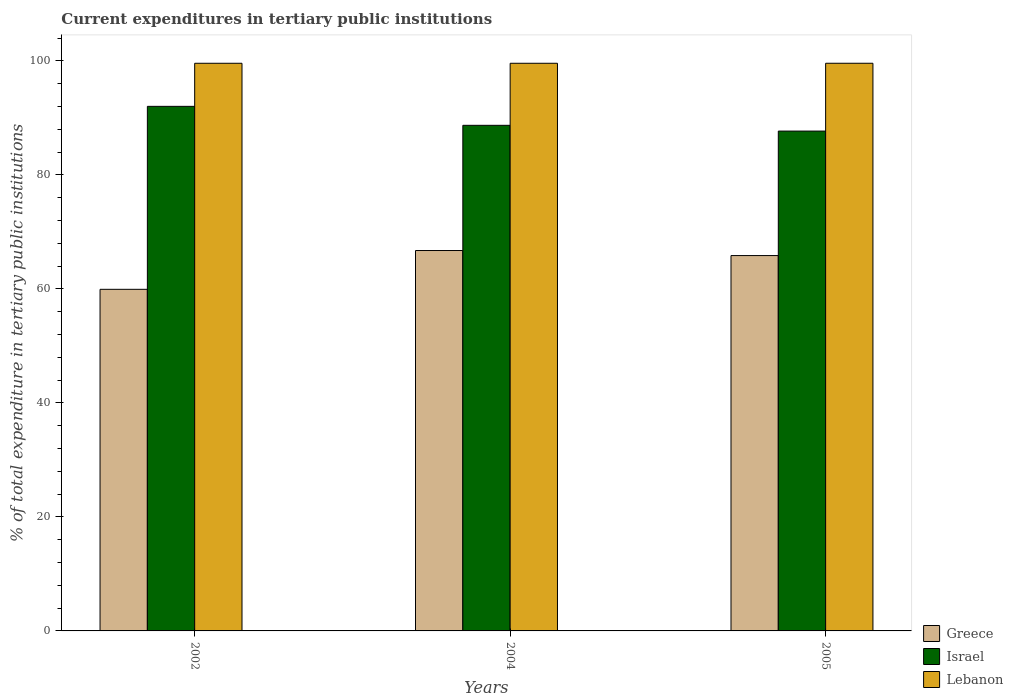How many different coloured bars are there?
Provide a succinct answer. 3. How many groups of bars are there?
Your answer should be very brief. 3. How many bars are there on the 2nd tick from the left?
Offer a very short reply. 3. How many bars are there on the 1st tick from the right?
Your response must be concise. 3. In how many cases, is the number of bars for a given year not equal to the number of legend labels?
Ensure brevity in your answer.  0. What is the current expenditures in tertiary public institutions in Israel in 2005?
Make the answer very short. 87.68. Across all years, what is the maximum current expenditures in tertiary public institutions in Israel?
Your answer should be very brief. 92.02. Across all years, what is the minimum current expenditures in tertiary public institutions in Greece?
Your response must be concise. 59.92. What is the total current expenditures in tertiary public institutions in Lebanon in the graph?
Your response must be concise. 298.72. What is the difference between the current expenditures in tertiary public institutions in Greece in 2002 and that in 2005?
Make the answer very short. -5.92. What is the difference between the current expenditures in tertiary public institutions in Lebanon in 2002 and the current expenditures in tertiary public institutions in Israel in 2004?
Make the answer very short. 10.88. What is the average current expenditures in tertiary public institutions in Israel per year?
Your answer should be very brief. 89.46. In the year 2002, what is the difference between the current expenditures in tertiary public institutions in Greece and current expenditures in tertiary public institutions in Lebanon?
Make the answer very short. -39.65. What is the ratio of the current expenditures in tertiary public institutions in Israel in 2004 to that in 2005?
Keep it short and to the point. 1.01. Is the current expenditures in tertiary public institutions in Lebanon in 2002 less than that in 2005?
Your response must be concise. Yes. What is the difference between the highest and the second highest current expenditures in tertiary public institutions in Israel?
Offer a terse response. 3.33. What is the difference between the highest and the lowest current expenditures in tertiary public institutions in Lebanon?
Ensure brevity in your answer.  0. Is the sum of the current expenditures in tertiary public institutions in Greece in 2004 and 2005 greater than the maximum current expenditures in tertiary public institutions in Israel across all years?
Your answer should be very brief. Yes. What does the 2nd bar from the left in 2005 represents?
Ensure brevity in your answer.  Israel. What does the 2nd bar from the right in 2004 represents?
Provide a short and direct response. Israel. What is the difference between two consecutive major ticks on the Y-axis?
Make the answer very short. 20. Are the values on the major ticks of Y-axis written in scientific E-notation?
Your answer should be compact. No. Does the graph contain grids?
Your answer should be very brief. No. How are the legend labels stacked?
Give a very brief answer. Vertical. What is the title of the graph?
Offer a very short reply. Current expenditures in tertiary public institutions. What is the label or title of the Y-axis?
Your answer should be compact. % of total expenditure in tertiary public institutions. What is the % of total expenditure in tertiary public institutions of Greece in 2002?
Keep it short and to the point. 59.92. What is the % of total expenditure in tertiary public institutions in Israel in 2002?
Offer a terse response. 92.02. What is the % of total expenditure in tertiary public institutions of Lebanon in 2002?
Give a very brief answer. 99.57. What is the % of total expenditure in tertiary public institutions of Greece in 2004?
Give a very brief answer. 66.73. What is the % of total expenditure in tertiary public institutions in Israel in 2004?
Your answer should be compact. 88.69. What is the % of total expenditure in tertiary public institutions of Lebanon in 2004?
Ensure brevity in your answer.  99.57. What is the % of total expenditure in tertiary public institutions of Greece in 2005?
Give a very brief answer. 65.84. What is the % of total expenditure in tertiary public institutions of Israel in 2005?
Keep it short and to the point. 87.68. What is the % of total expenditure in tertiary public institutions of Lebanon in 2005?
Provide a short and direct response. 99.58. Across all years, what is the maximum % of total expenditure in tertiary public institutions in Greece?
Give a very brief answer. 66.73. Across all years, what is the maximum % of total expenditure in tertiary public institutions in Israel?
Offer a very short reply. 92.02. Across all years, what is the maximum % of total expenditure in tertiary public institutions of Lebanon?
Your answer should be compact. 99.58. Across all years, what is the minimum % of total expenditure in tertiary public institutions of Greece?
Your answer should be compact. 59.92. Across all years, what is the minimum % of total expenditure in tertiary public institutions of Israel?
Provide a succinct answer. 87.68. Across all years, what is the minimum % of total expenditure in tertiary public institutions of Lebanon?
Provide a succinct answer. 99.57. What is the total % of total expenditure in tertiary public institutions of Greece in the graph?
Give a very brief answer. 192.49. What is the total % of total expenditure in tertiary public institutions in Israel in the graph?
Offer a terse response. 268.39. What is the total % of total expenditure in tertiary public institutions in Lebanon in the graph?
Your answer should be very brief. 298.72. What is the difference between the % of total expenditure in tertiary public institutions in Greece in 2002 and that in 2004?
Your answer should be very brief. -6.81. What is the difference between the % of total expenditure in tertiary public institutions of Israel in 2002 and that in 2004?
Offer a terse response. 3.33. What is the difference between the % of total expenditure in tertiary public institutions of Lebanon in 2002 and that in 2004?
Offer a very short reply. -0. What is the difference between the % of total expenditure in tertiary public institutions of Greece in 2002 and that in 2005?
Provide a succinct answer. -5.92. What is the difference between the % of total expenditure in tertiary public institutions in Israel in 2002 and that in 2005?
Give a very brief answer. 4.34. What is the difference between the % of total expenditure in tertiary public institutions in Lebanon in 2002 and that in 2005?
Offer a very short reply. -0. What is the difference between the % of total expenditure in tertiary public institutions in Greece in 2004 and that in 2005?
Keep it short and to the point. 0.89. What is the difference between the % of total expenditure in tertiary public institutions in Israel in 2004 and that in 2005?
Offer a terse response. 1.01. What is the difference between the % of total expenditure in tertiary public institutions in Lebanon in 2004 and that in 2005?
Offer a very short reply. -0. What is the difference between the % of total expenditure in tertiary public institutions of Greece in 2002 and the % of total expenditure in tertiary public institutions of Israel in 2004?
Make the answer very short. -28.77. What is the difference between the % of total expenditure in tertiary public institutions in Greece in 2002 and the % of total expenditure in tertiary public institutions in Lebanon in 2004?
Keep it short and to the point. -39.65. What is the difference between the % of total expenditure in tertiary public institutions of Israel in 2002 and the % of total expenditure in tertiary public institutions of Lebanon in 2004?
Your answer should be compact. -7.56. What is the difference between the % of total expenditure in tertiary public institutions in Greece in 2002 and the % of total expenditure in tertiary public institutions in Israel in 2005?
Make the answer very short. -27.76. What is the difference between the % of total expenditure in tertiary public institutions in Greece in 2002 and the % of total expenditure in tertiary public institutions in Lebanon in 2005?
Offer a terse response. -39.66. What is the difference between the % of total expenditure in tertiary public institutions of Israel in 2002 and the % of total expenditure in tertiary public institutions of Lebanon in 2005?
Offer a terse response. -7.56. What is the difference between the % of total expenditure in tertiary public institutions of Greece in 2004 and the % of total expenditure in tertiary public institutions of Israel in 2005?
Your response must be concise. -20.95. What is the difference between the % of total expenditure in tertiary public institutions in Greece in 2004 and the % of total expenditure in tertiary public institutions in Lebanon in 2005?
Your answer should be compact. -32.85. What is the difference between the % of total expenditure in tertiary public institutions in Israel in 2004 and the % of total expenditure in tertiary public institutions in Lebanon in 2005?
Keep it short and to the point. -10.89. What is the average % of total expenditure in tertiary public institutions of Greece per year?
Your answer should be compact. 64.16. What is the average % of total expenditure in tertiary public institutions in Israel per year?
Keep it short and to the point. 89.46. What is the average % of total expenditure in tertiary public institutions in Lebanon per year?
Provide a succinct answer. 99.57. In the year 2002, what is the difference between the % of total expenditure in tertiary public institutions in Greece and % of total expenditure in tertiary public institutions in Israel?
Your response must be concise. -32.1. In the year 2002, what is the difference between the % of total expenditure in tertiary public institutions of Greece and % of total expenditure in tertiary public institutions of Lebanon?
Give a very brief answer. -39.65. In the year 2002, what is the difference between the % of total expenditure in tertiary public institutions in Israel and % of total expenditure in tertiary public institutions in Lebanon?
Provide a succinct answer. -7.56. In the year 2004, what is the difference between the % of total expenditure in tertiary public institutions in Greece and % of total expenditure in tertiary public institutions in Israel?
Give a very brief answer. -21.96. In the year 2004, what is the difference between the % of total expenditure in tertiary public institutions in Greece and % of total expenditure in tertiary public institutions in Lebanon?
Your response must be concise. -32.85. In the year 2004, what is the difference between the % of total expenditure in tertiary public institutions of Israel and % of total expenditure in tertiary public institutions of Lebanon?
Your answer should be compact. -10.88. In the year 2005, what is the difference between the % of total expenditure in tertiary public institutions of Greece and % of total expenditure in tertiary public institutions of Israel?
Make the answer very short. -21.84. In the year 2005, what is the difference between the % of total expenditure in tertiary public institutions in Greece and % of total expenditure in tertiary public institutions in Lebanon?
Offer a terse response. -33.73. In the year 2005, what is the difference between the % of total expenditure in tertiary public institutions in Israel and % of total expenditure in tertiary public institutions in Lebanon?
Offer a terse response. -11.9. What is the ratio of the % of total expenditure in tertiary public institutions in Greece in 2002 to that in 2004?
Your response must be concise. 0.9. What is the ratio of the % of total expenditure in tertiary public institutions in Israel in 2002 to that in 2004?
Provide a short and direct response. 1.04. What is the ratio of the % of total expenditure in tertiary public institutions of Lebanon in 2002 to that in 2004?
Provide a short and direct response. 1. What is the ratio of the % of total expenditure in tertiary public institutions in Greece in 2002 to that in 2005?
Your answer should be very brief. 0.91. What is the ratio of the % of total expenditure in tertiary public institutions of Israel in 2002 to that in 2005?
Your answer should be very brief. 1.05. What is the ratio of the % of total expenditure in tertiary public institutions of Greece in 2004 to that in 2005?
Ensure brevity in your answer.  1.01. What is the ratio of the % of total expenditure in tertiary public institutions of Israel in 2004 to that in 2005?
Offer a very short reply. 1.01. What is the ratio of the % of total expenditure in tertiary public institutions in Lebanon in 2004 to that in 2005?
Your answer should be very brief. 1. What is the difference between the highest and the second highest % of total expenditure in tertiary public institutions in Greece?
Your answer should be compact. 0.89. What is the difference between the highest and the second highest % of total expenditure in tertiary public institutions in Israel?
Make the answer very short. 3.33. What is the difference between the highest and the second highest % of total expenditure in tertiary public institutions in Lebanon?
Keep it short and to the point. 0. What is the difference between the highest and the lowest % of total expenditure in tertiary public institutions in Greece?
Provide a succinct answer. 6.81. What is the difference between the highest and the lowest % of total expenditure in tertiary public institutions in Israel?
Ensure brevity in your answer.  4.34. What is the difference between the highest and the lowest % of total expenditure in tertiary public institutions of Lebanon?
Provide a succinct answer. 0. 